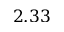<formula> <loc_0><loc_0><loc_500><loc_500>2 . 3 3</formula> 